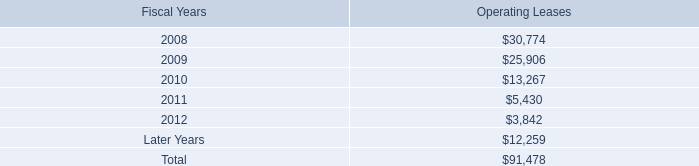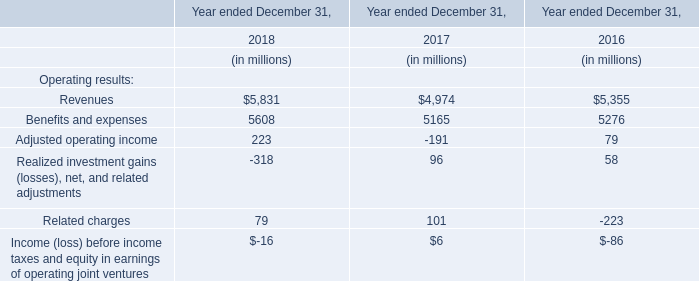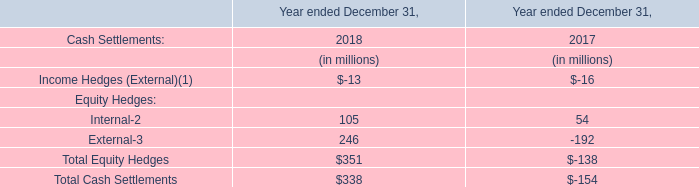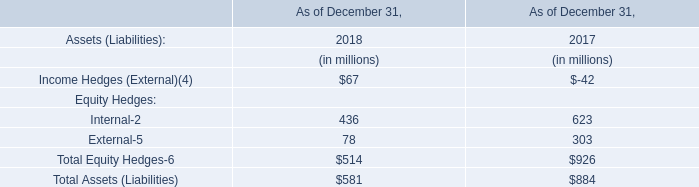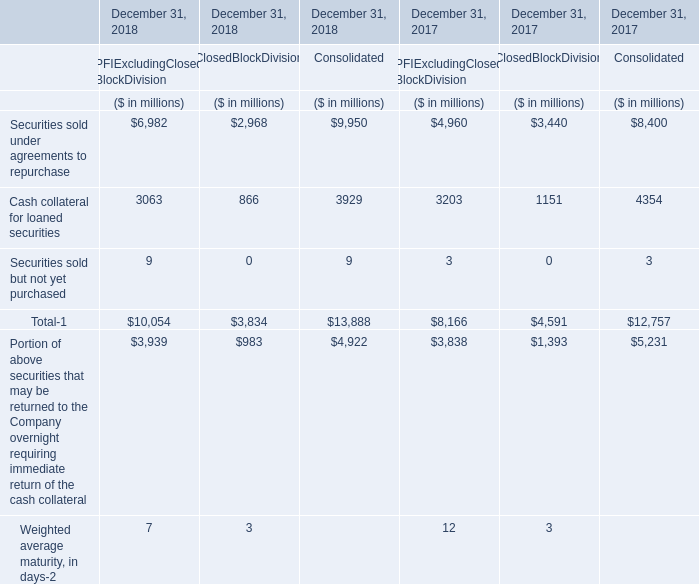What is the growing rate of Total-1 in the year with the least Securities sold under agreements to repurchase? 
Computations: ((((10054 + 3834) + 13888) - ((8166 + 4591) + 12757)) / ((8166 + 4591) + 12757))
Answer: 0.08866. 